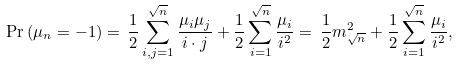Convert formula to latex. <formula><loc_0><loc_0><loc_500><loc_500>\Pr \left ( \mu _ { n } = - 1 \right ) = \, \frac { 1 } { 2 } \sum _ { i , j = 1 } ^ { \sqrt { n } } \frac { \mu _ { i } \mu _ { j } } { i \cdot j } + \frac { 1 } { 2 } \sum _ { i = 1 } ^ { \sqrt { n } } \frac { \mu _ { i } } { i ^ { 2 } } = \, \frac { 1 } { 2 } m _ { \sqrt { n } } ^ { 2 } + \frac { 1 } { 2 } \sum _ { i = 1 } ^ { \sqrt { n } } \frac { \mu _ { i } } { i ^ { 2 } } ,</formula> 